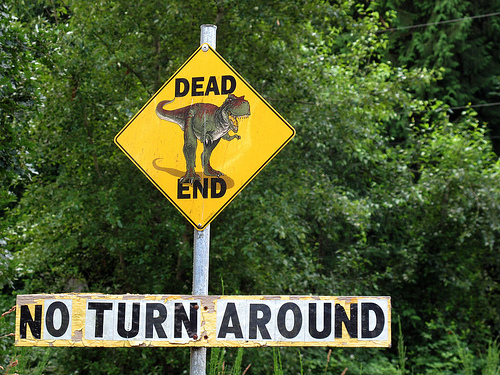<image>
Is the dinosaur in the woods? No. The dinosaur is not contained within the woods. These objects have a different spatial relationship. Is the sign in front of the tree? Yes. The sign is positioned in front of the tree, appearing closer to the camera viewpoint. 